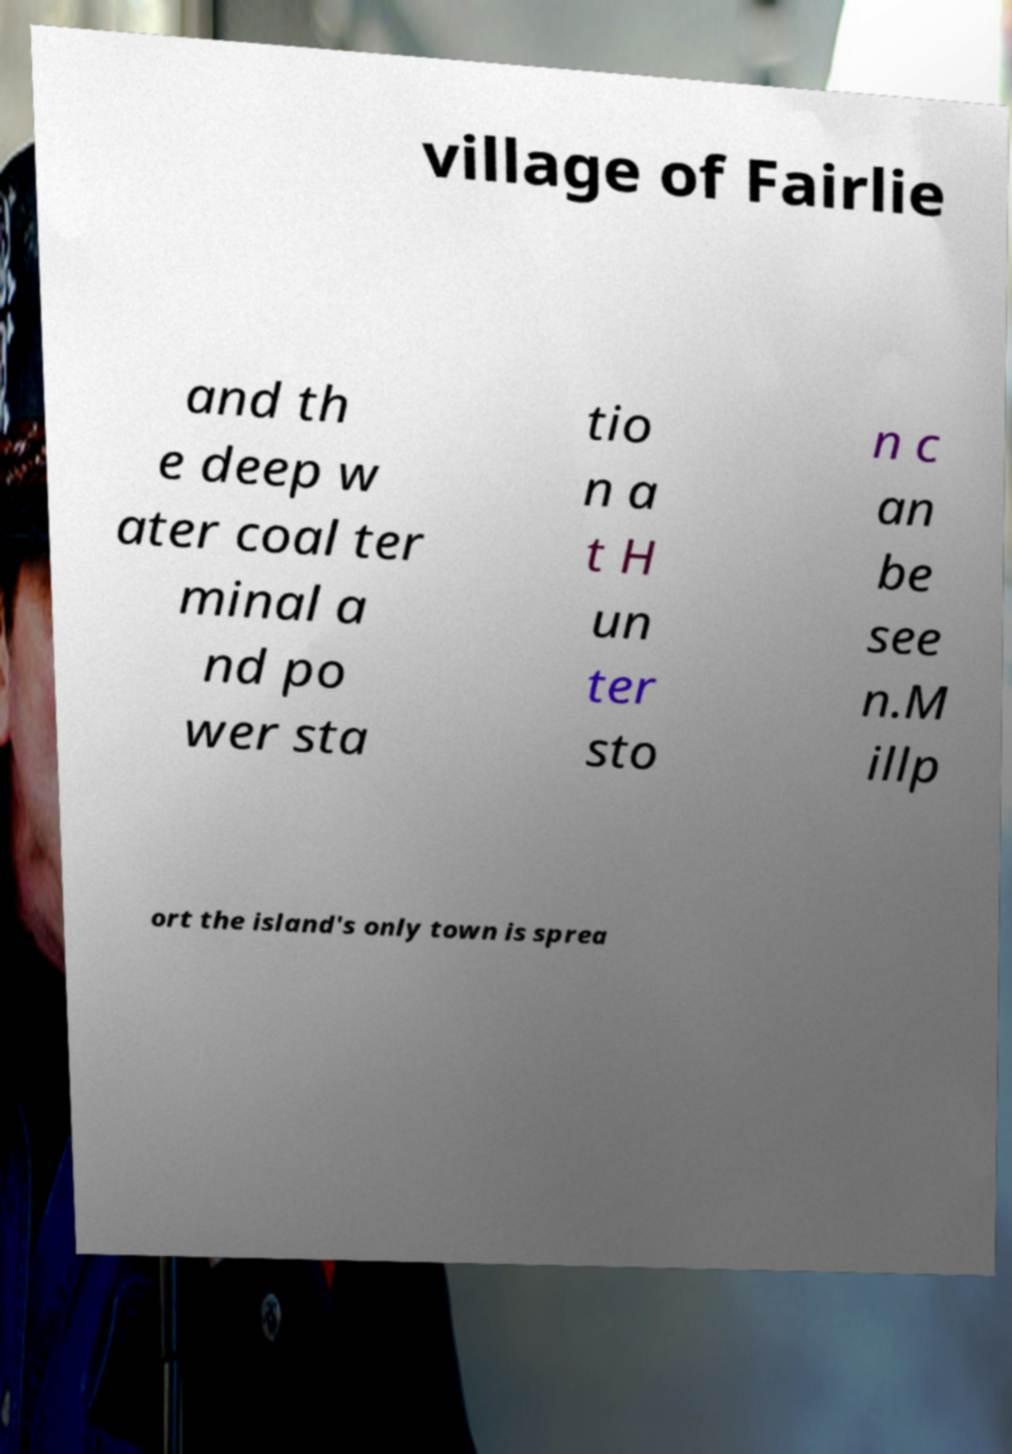Please read and relay the text visible in this image. What does it say? village of Fairlie and th e deep w ater coal ter minal a nd po wer sta tio n a t H un ter sto n c an be see n.M illp ort the island's only town is sprea 